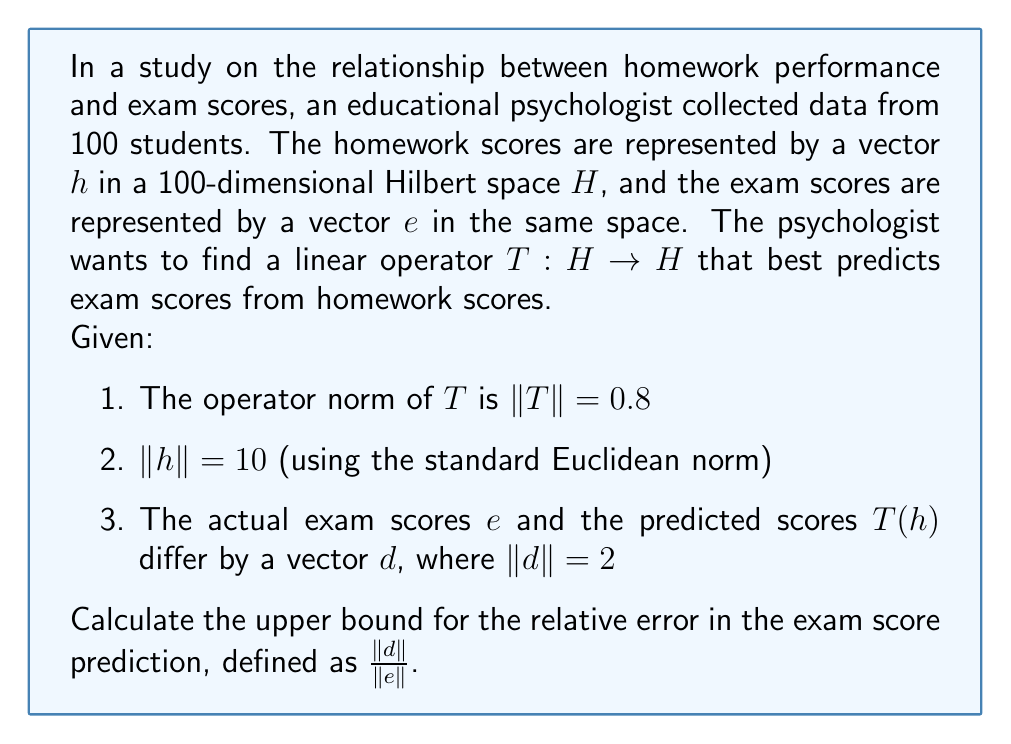Can you answer this question? Let's approach this step-by-step:

1) First, recall that for any linear operator $T$ and vector $x$, we have:
   $$\|T(x)\| \leq \|T\| \cdot \|x\|$$

2) In our case, this means:
   $$\|T(h)\| \leq \|T\| \cdot \|h\| = 0.8 \cdot 10 = 8$$

3) Now, we know that $e = T(h) + d$. Taking norms of both sides:
   $$\|e\| = \|T(h) + d\|$$

4) By the triangle inequality:
   $$\|e\| \leq \|T(h)\| + \|d\|$$

5) Substituting the values we know:
   $$\|e\| \leq 8 + 2 = 10$$

6) The relative error is defined as $\frac{\|d\|}{\|e\|}$. We want to find an upper bound for this.

7) Since $\|d\| = 2$ and $\|e\| \geq \|T(h)\| - \|d\| \geq 8 - 2 = 6$ (using reverse triangle inequality), we can say:

   $$\frac{\|d\|}{\|e\|} \leq \frac{2}{6} = \frac{1}{3}$$

8) Therefore, the upper bound for the relative error is $\frac{1}{3}$ or approximately 0.333 or 33.3%.

This means that the predicted exam scores may deviate from the actual scores by at most 33.3% relative to the magnitude of the actual scores.
Answer: $\frac{1}{3}$ or 33.3% 